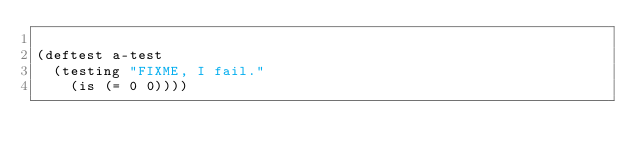Convert code to text. <code><loc_0><loc_0><loc_500><loc_500><_Clojure_>
(deftest a-test
  (testing "FIXME, I fail."
    (is (= 0 0))))
</code> 